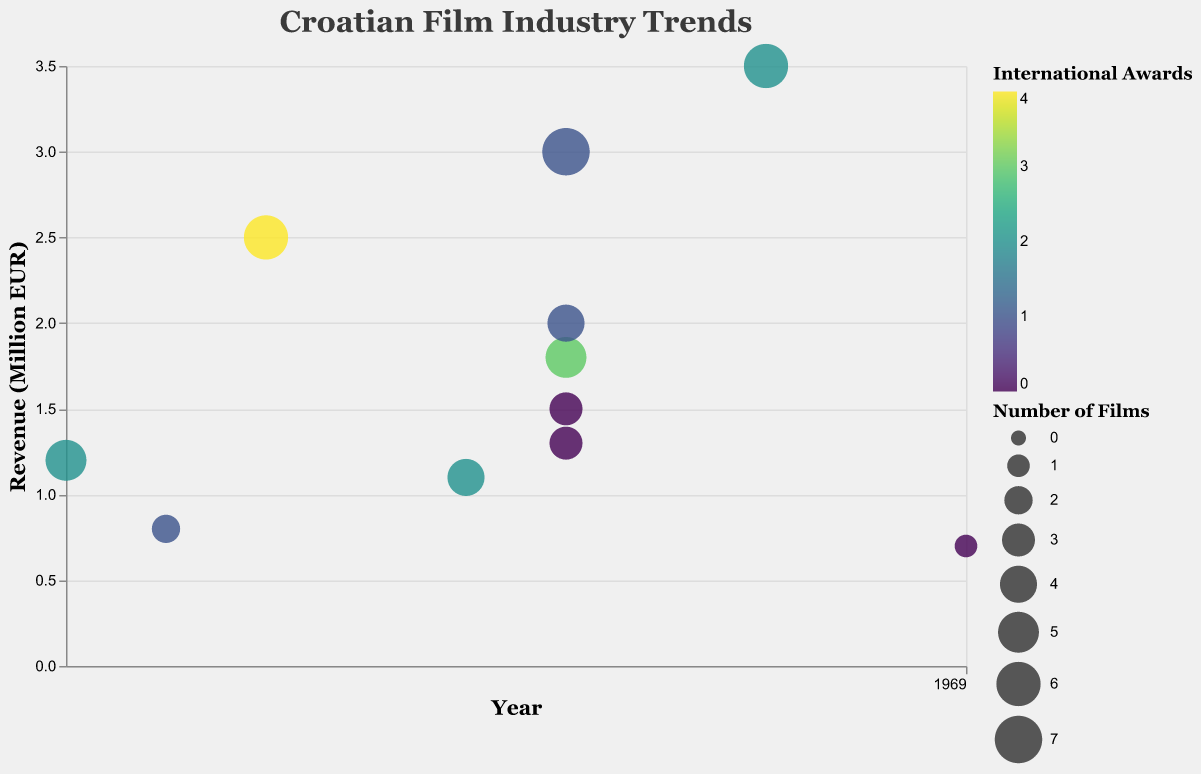What is the title of the chart? The title of the chart is prominently displayed at the top and indicates the main topic of the visualization.
Answer: Croatian Film Industry Trends Which year had the highest revenue for Croatian films? Looking at the x-axis for years and y-axis for revenue, the highest point on the revenue scale corresponds to the year 2018.
Answer: 2018 How many films were produced in 2016? By examining the sizes of the bubbles for the year 2016, there are multiple data points representing different films, all with varying bubble sizes indicating the number of films produced. Counting these, we get five films.
Answer: 5 Which film won the most international awards and in what year was it released? The bubble color represents international awards won, and the darkest bubble indicates the highest number of awards. This corresponds to "The Priest's Children" released in 2013.
Answer: The Priest's Children, 2013 What is the average revenue of films released in 2016? To find the average, sum up all revenue values for the films released in 2016 and divide by the number of films. The films and revenues are: A Stranger (3.0), On the Other Side (1.8), Ministry of Love (1.5), Quit Staring at My Plate (2.0), All the Best (1.3). Their total revenue is 9.6 million EUR, divided by 5 gives 1.92.
Answer: 1.92 million EUR Which year produced the fewest number of films and what was the revenue for that year? The smallest bubble size indicates the fewest films produced. Checking the bubble sizes, 2020 has the smallest, corresponding to only 1 film with revenue of 0.7 million EUR.
Answer: 2020, 0.7 million EUR Compare the number of international awards won in 2011 and 2018. Which year won more? Checking the color of the bubbles for these years, 2011 shows a lighter color with 2 awards, while 2018 shows a similar color indicating 2 awards as well.
Answer: Same, both won 2 awards Which film had the highest revenue and how many films were produced for it? The largest bubble on the highest point on the y-axis indicates the highest revenue. The film is "The Eighth Commissioner" with 6 films produced.
Answer: The Eighth Commissioner, 6 films How many international awards were won by all films produced in 2016? Summing up the international awards for each film produced in 2016: A Stranger (1), On the Other Side (3), Ministry of Love (0), Quit Staring at My Plate (1), All the Best (0). Total awards is 1 + 3 + 0 + 1 + 0 = 5.
Answer: 5 Which film produced in 2015 had the lowest revenue and how many international awards did it win? For 2015, checking the respective films and their revenues, "The High Sun" has the lowest with 1.1 million EUR and it won 2 international awards.
Answer: The High Sun, 2 awards 